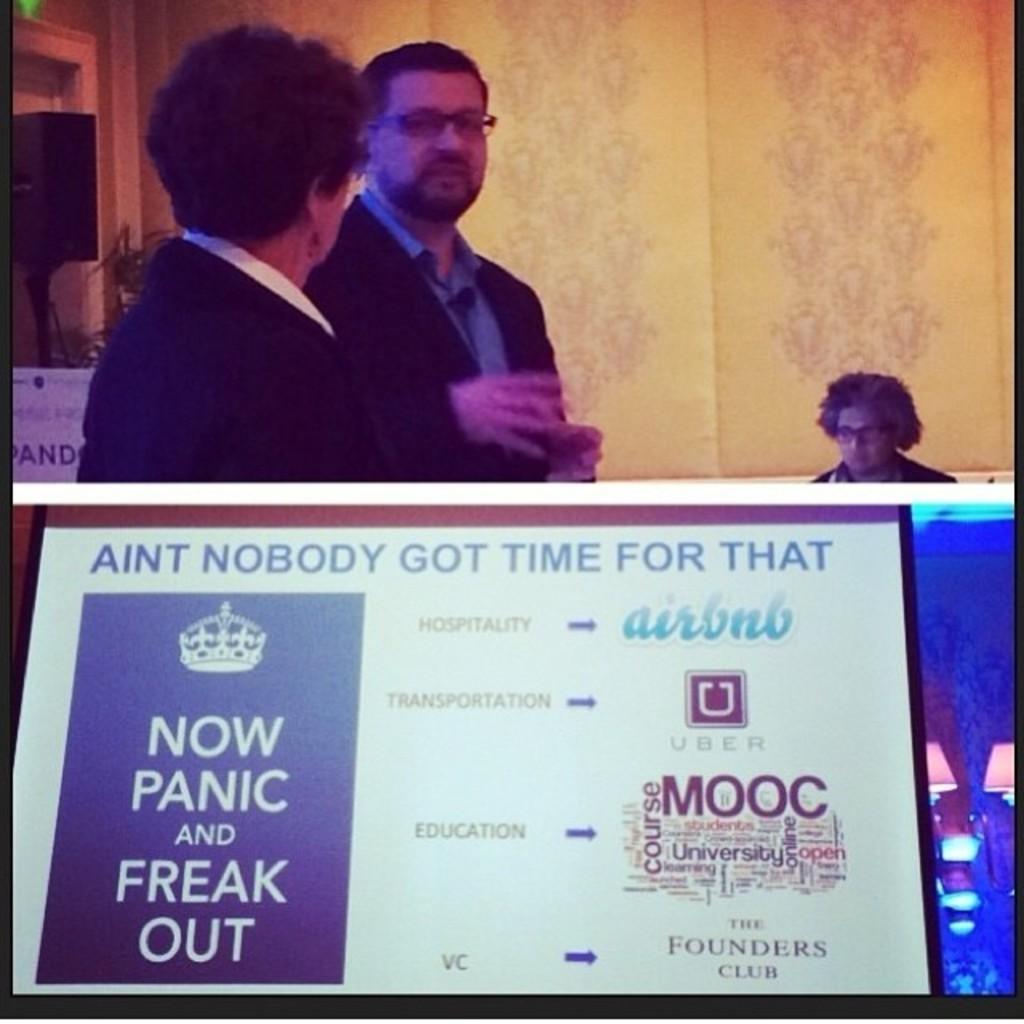Could you give a brief overview of what you see in this image? This picture seems to be be clicked inside. In the foreground we can see a board on which the text is printed. On the right corner we can see the lamps. On the left there are two persons standing on the ground. In the background we can see the wall, a person and some other objects. 